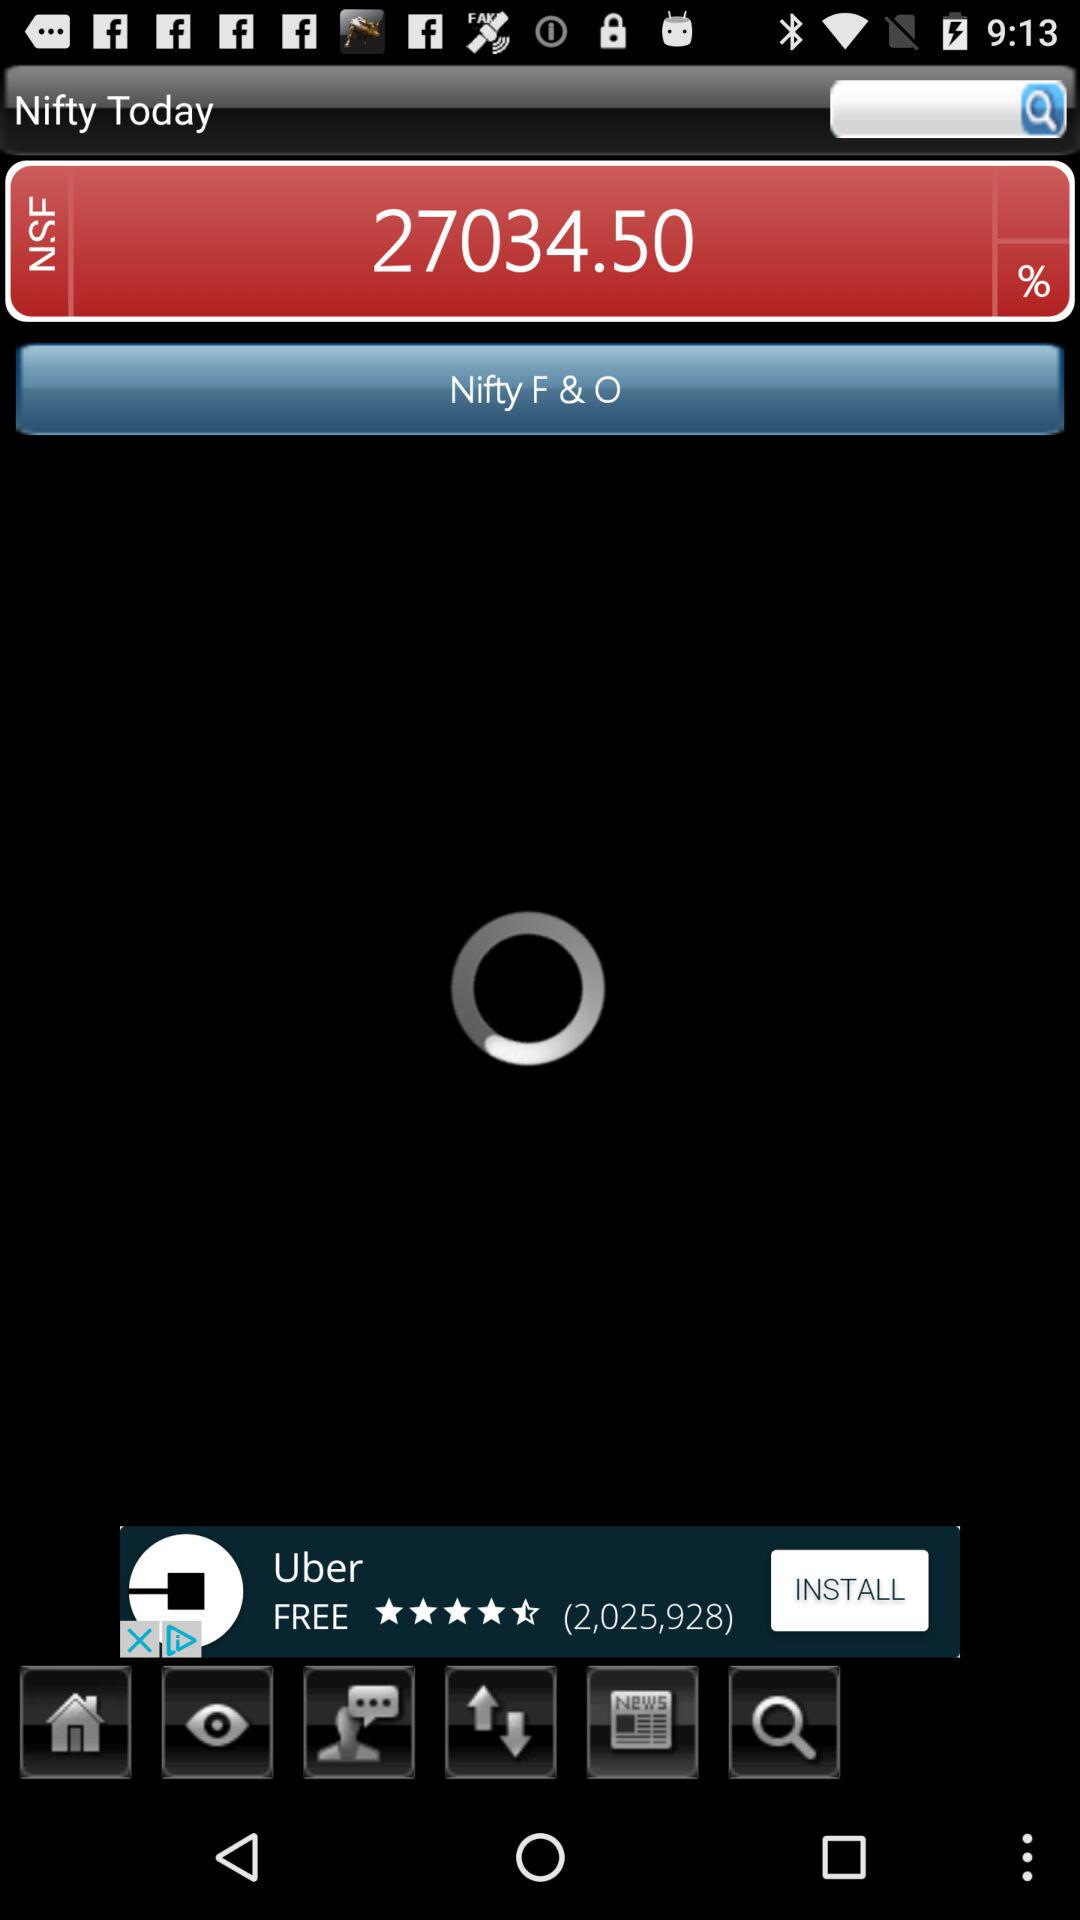What is the Nifty today? Today's nifty is 27034.50. 